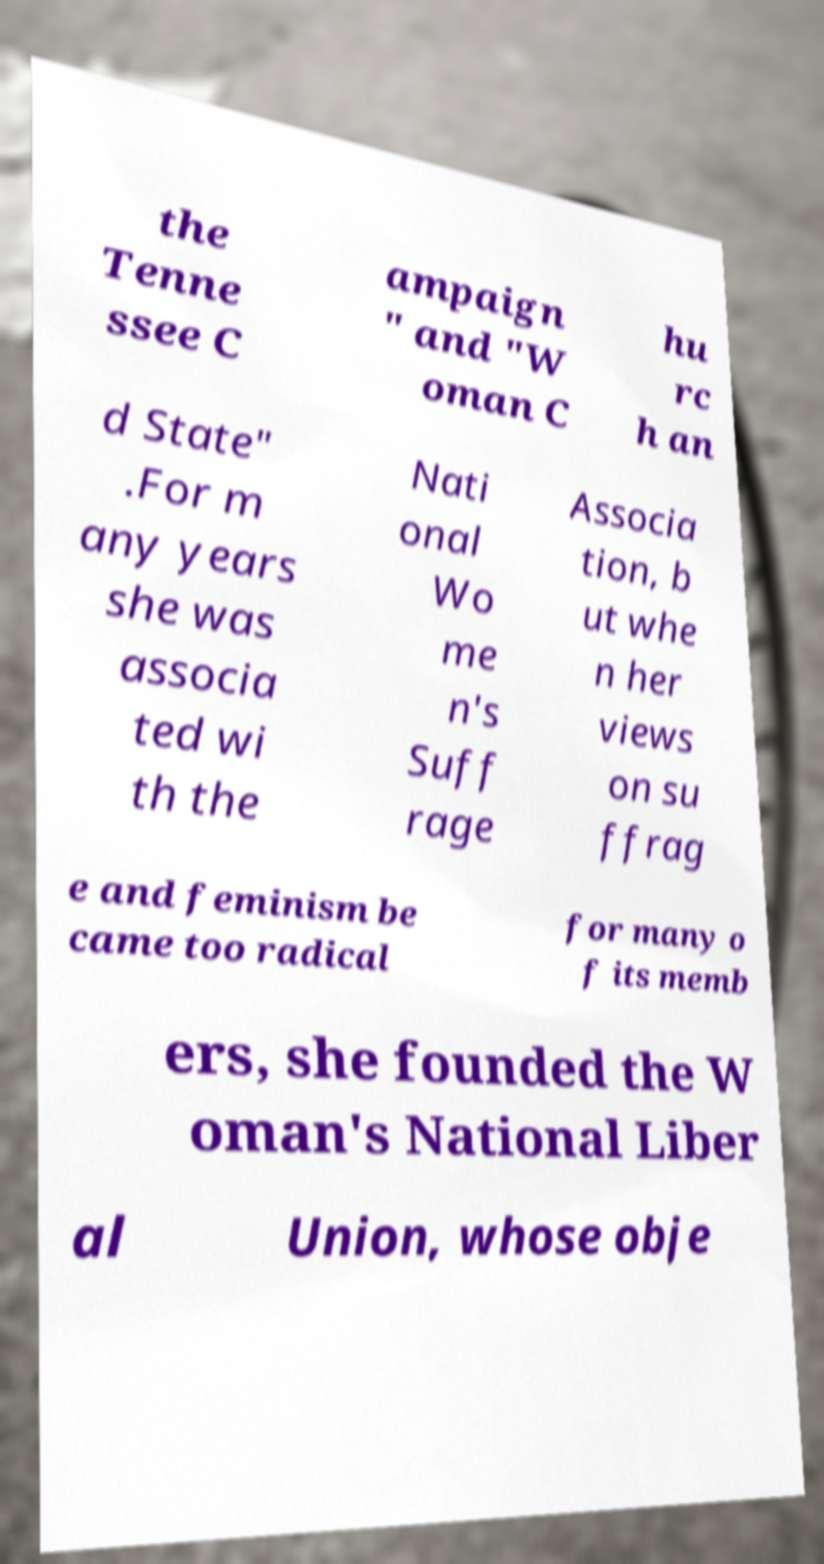Could you assist in decoding the text presented in this image and type it out clearly? the Tenne ssee C ampaign " and "W oman C hu rc h an d State" .For m any years she was associa ted wi th the Nati onal Wo me n's Suff rage Associa tion, b ut whe n her views on su ffrag e and feminism be came too radical for many o f its memb ers, she founded the W oman's National Liber al Union, whose obje 